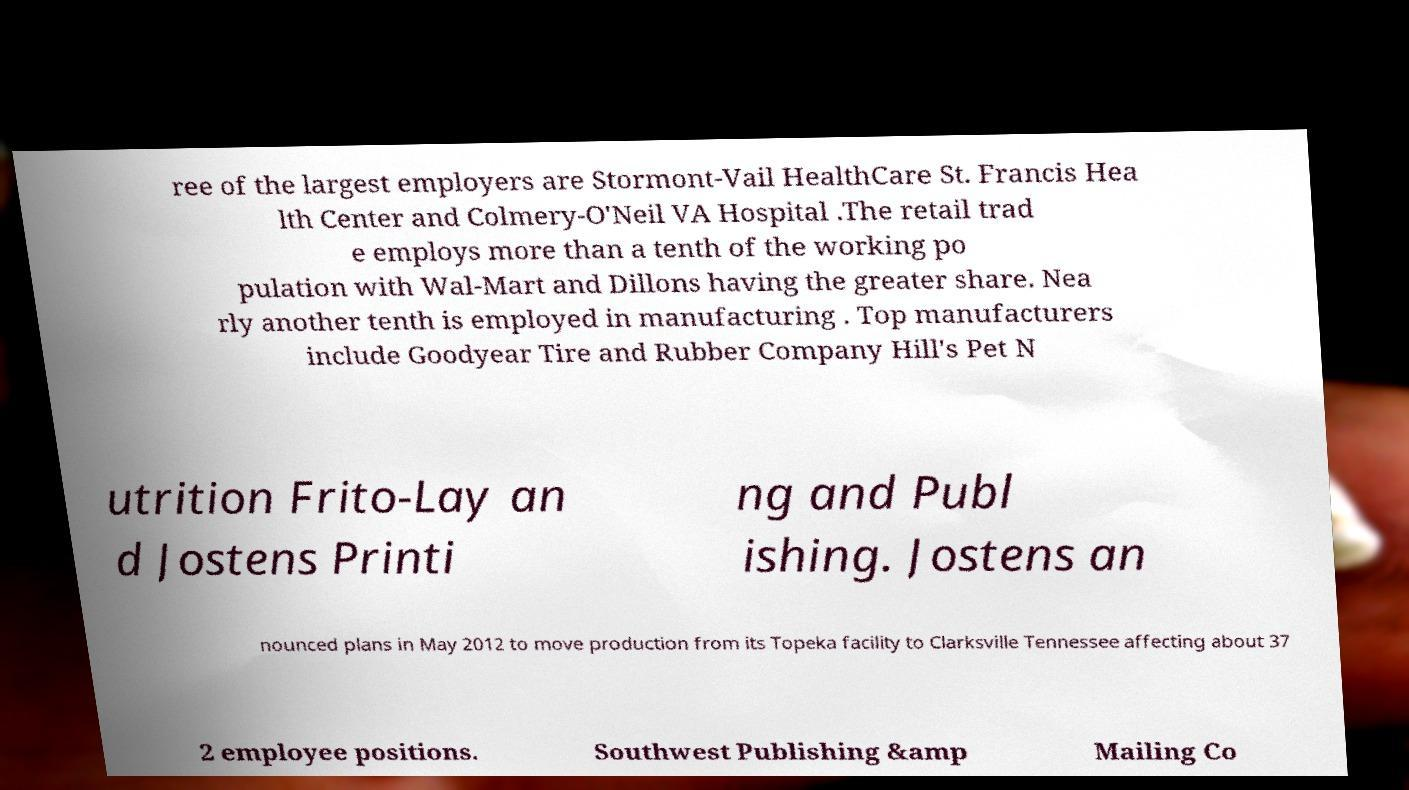For documentation purposes, I need the text within this image transcribed. Could you provide that? ree of the largest employers are Stormont-Vail HealthCare St. Francis Hea lth Center and Colmery-O'Neil VA Hospital .The retail trad e employs more than a tenth of the working po pulation with Wal-Mart and Dillons having the greater share. Nea rly another tenth is employed in manufacturing . Top manufacturers include Goodyear Tire and Rubber Company Hill's Pet N utrition Frito-Lay an d Jostens Printi ng and Publ ishing. Jostens an nounced plans in May 2012 to move production from its Topeka facility to Clarksville Tennessee affecting about 37 2 employee positions. Southwest Publishing &amp Mailing Co 